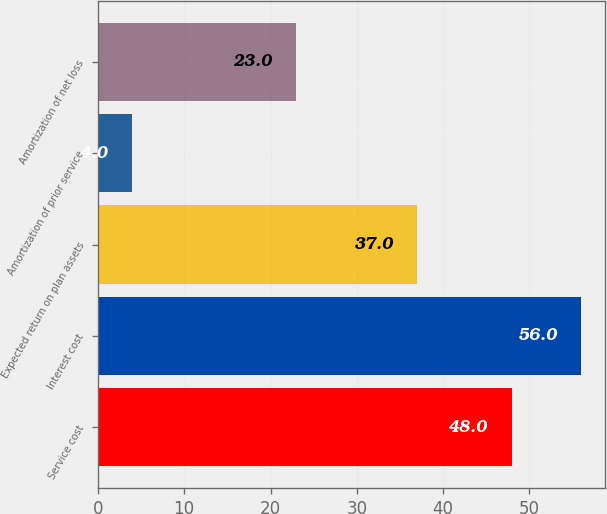Convert chart to OTSL. <chart><loc_0><loc_0><loc_500><loc_500><bar_chart><fcel>Service cost<fcel>Interest cost<fcel>Expected return on plan assets<fcel>Amortization of prior service<fcel>Amortization of net loss<nl><fcel>48<fcel>56<fcel>37<fcel>4<fcel>23<nl></chart> 